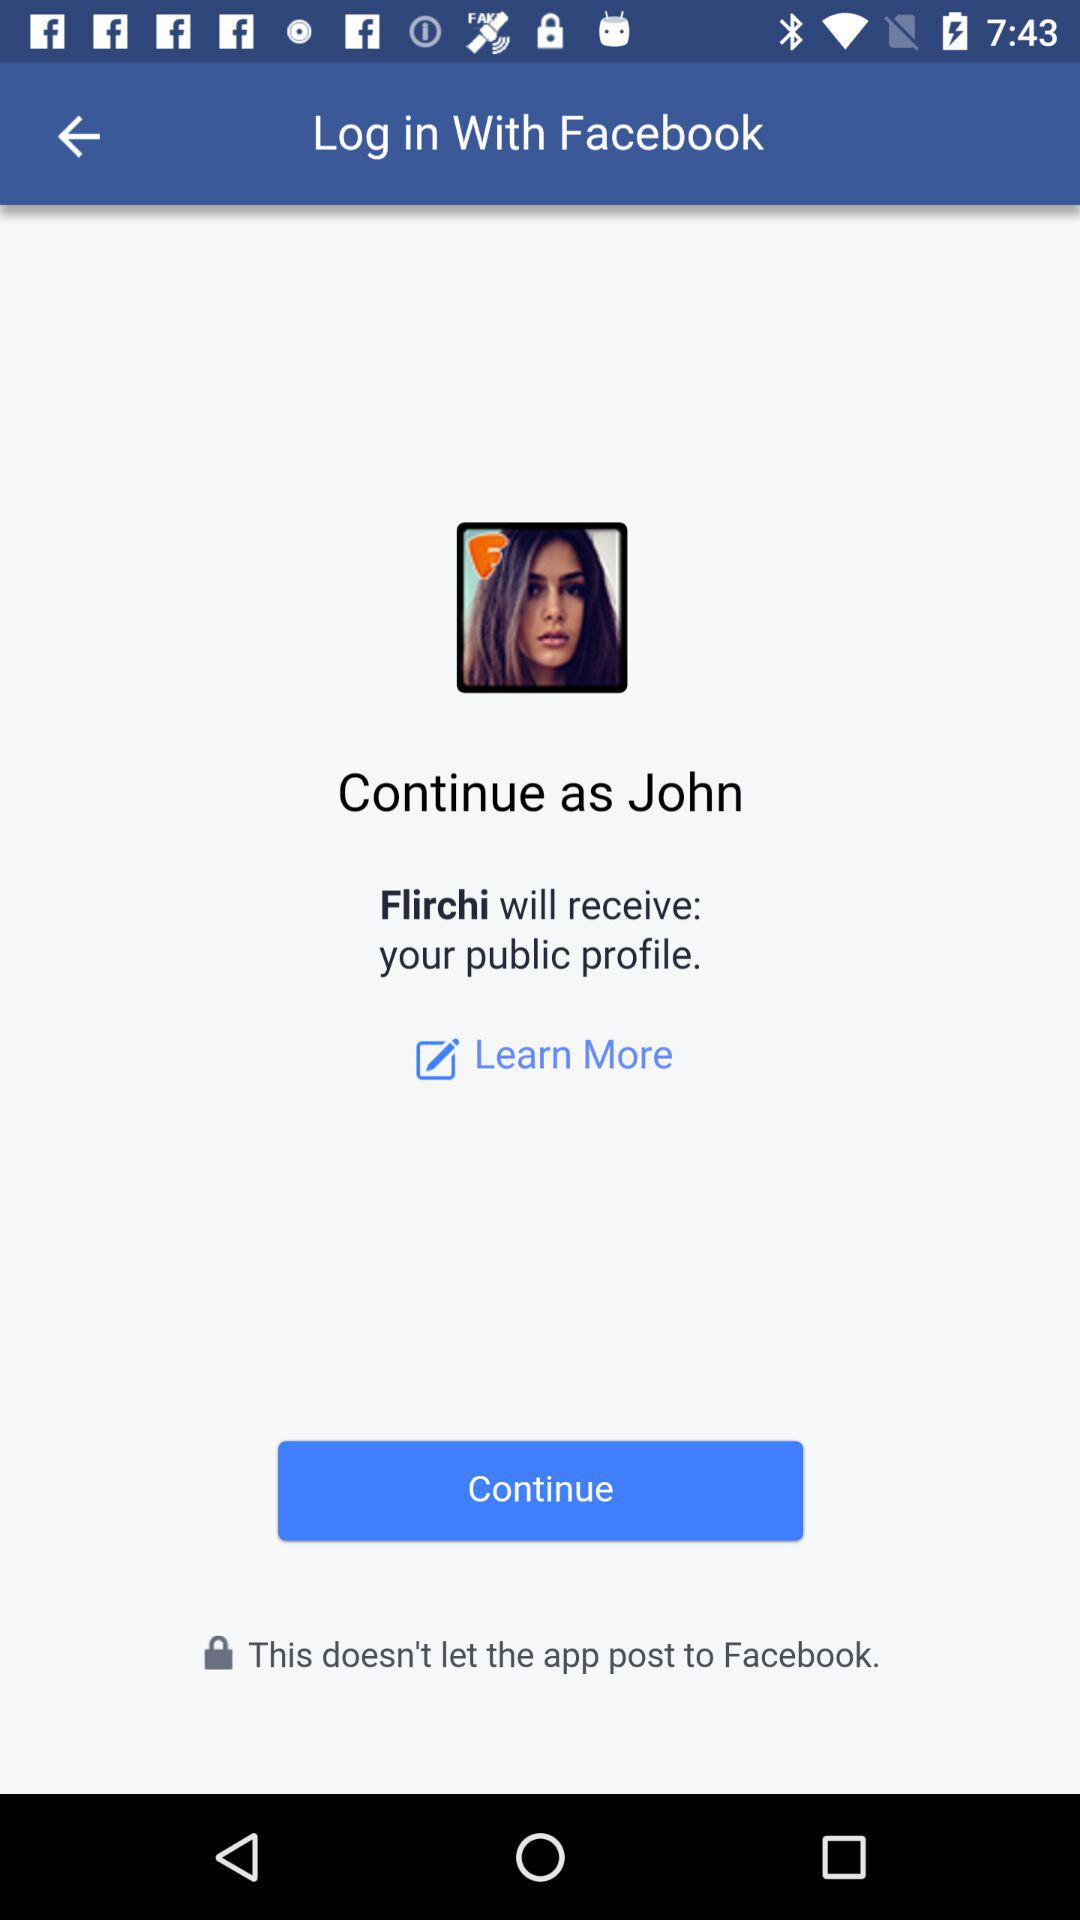What application is asking for permission? The application asking for permission is "Flirchi". 